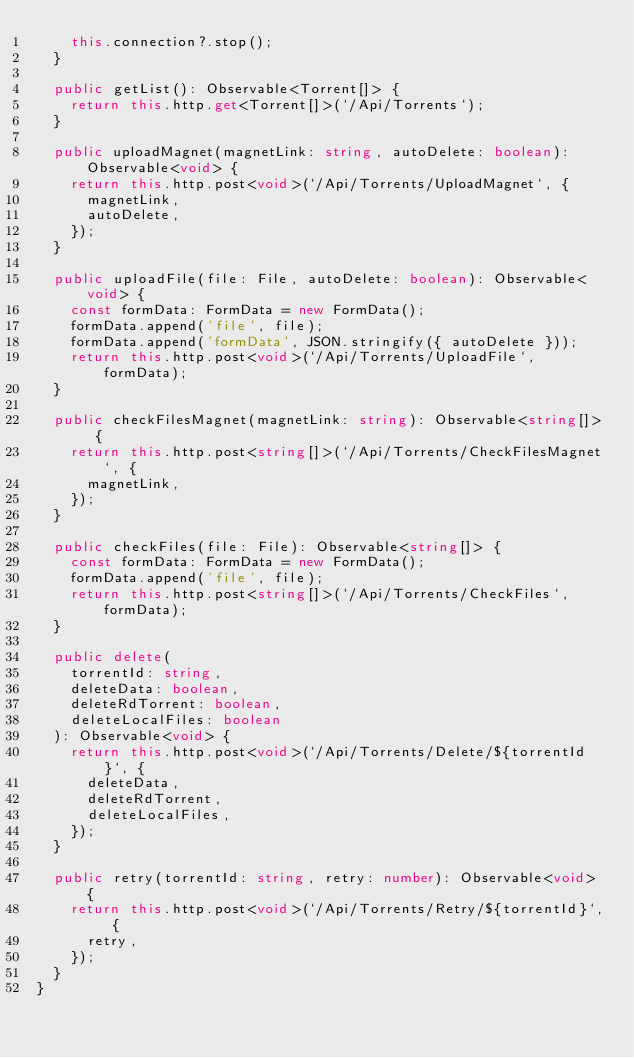Convert code to text. <code><loc_0><loc_0><loc_500><loc_500><_TypeScript_>    this.connection?.stop();
  }

  public getList(): Observable<Torrent[]> {
    return this.http.get<Torrent[]>(`/Api/Torrents`);
  }

  public uploadMagnet(magnetLink: string, autoDelete: boolean): Observable<void> {
    return this.http.post<void>(`/Api/Torrents/UploadMagnet`, {
      magnetLink,
      autoDelete,
    });
  }

  public uploadFile(file: File, autoDelete: boolean): Observable<void> {
    const formData: FormData = new FormData();
    formData.append('file', file);
    formData.append('formData', JSON.stringify({ autoDelete }));
    return this.http.post<void>(`/Api/Torrents/UploadFile`, formData);
  }

  public checkFilesMagnet(magnetLink: string): Observable<string[]> {
    return this.http.post<string[]>(`/Api/Torrents/CheckFilesMagnet`, {
      magnetLink,
    });
  }

  public checkFiles(file: File): Observable<string[]> {
    const formData: FormData = new FormData();
    formData.append('file', file);
    return this.http.post<string[]>(`/Api/Torrents/CheckFiles`, formData);
  }

  public delete(
    torrentId: string,
    deleteData: boolean,
    deleteRdTorrent: boolean,
    deleteLocalFiles: boolean
  ): Observable<void> {
    return this.http.post<void>(`/Api/Torrents/Delete/${torrentId}`, {
      deleteData,
      deleteRdTorrent,
      deleteLocalFiles,
    });
  }

  public retry(torrentId: string, retry: number): Observable<void> {
    return this.http.post<void>(`/Api/Torrents/Retry/${torrentId}`, {
      retry,
    });
  }
}
</code> 